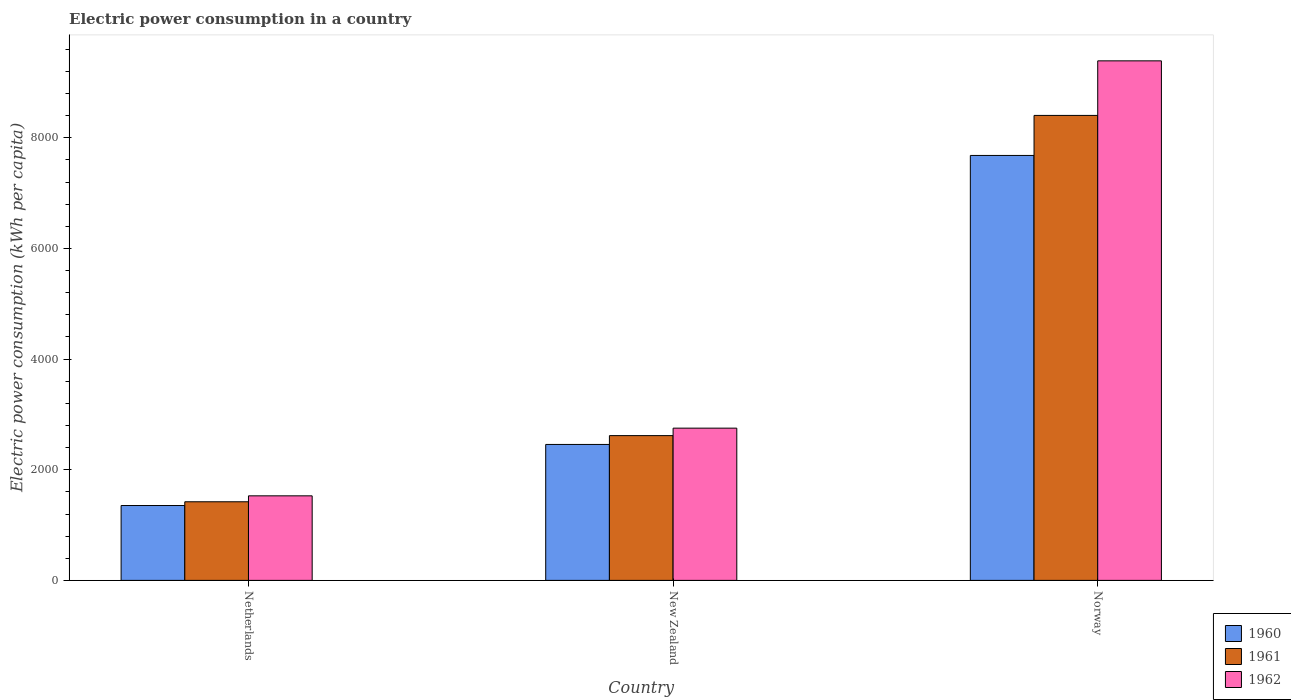How many different coloured bars are there?
Offer a very short reply. 3. Are the number of bars per tick equal to the number of legend labels?
Ensure brevity in your answer.  Yes. How many bars are there on the 3rd tick from the right?
Provide a short and direct response. 3. What is the label of the 3rd group of bars from the left?
Provide a succinct answer. Norway. In how many cases, is the number of bars for a given country not equal to the number of legend labels?
Your answer should be very brief. 0. What is the electric power consumption in in 1961 in Norway?
Your response must be concise. 8404.62. Across all countries, what is the maximum electric power consumption in in 1960?
Keep it short and to the point. 7681.14. Across all countries, what is the minimum electric power consumption in in 1960?
Make the answer very short. 1353.4. In which country was the electric power consumption in in 1960 maximum?
Keep it short and to the point. Norway. What is the total electric power consumption in in 1961 in the graph?
Provide a succinct answer. 1.24e+04. What is the difference between the electric power consumption in in 1961 in New Zealand and that in Norway?
Provide a short and direct response. -5787.77. What is the difference between the electric power consumption in in 1961 in New Zealand and the electric power consumption in in 1962 in Norway?
Give a very brief answer. -6774.12. What is the average electric power consumption in in 1961 per country?
Ensure brevity in your answer.  4147.5. What is the difference between the electric power consumption in of/in 1960 and electric power consumption in of/in 1961 in Norway?
Your response must be concise. -723.48. What is the ratio of the electric power consumption in in 1960 in Netherlands to that in Norway?
Ensure brevity in your answer.  0.18. Is the difference between the electric power consumption in in 1960 in Netherlands and Norway greater than the difference between the electric power consumption in in 1961 in Netherlands and Norway?
Your answer should be very brief. Yes. What is the difference between the highest and the second highest electric power consumption in in 1962?
Your answer should be compact. -7862.48. What is the difference between the highest and the lowest electric power consumption in in 1961?
Provide a short and direct response. 6983.59. What does the 3rd bar from the left in Norway represents?
Give a very brief answer. 1962. What is the difference between two consecutive major ticks on the Y-axis?
Provide a succinct answer. 2000. Where does the legend appear in the graph?
Your answer should be compact. Bottom right. How many legend labels are there?
Your answer should be very brief. 3. How are the legend labels stacked?
Your response must be concise. Vertical. What is the title of the graph?
Provide a succinct answer. Electric power consumption in a country. Does "2003" appear as one of the legend labels in the graph?
Offer a very short reply. No. What is the label or title of the X-axis?
Make the answer very short. Country. What is the label or title of the Y-axis?
Make the answer very short. Electric power consumption (kWh per capita). What is the Electric power consumption (kWh per capita) of 1960 in Netherlands?
Offer a terse response. 1353.4. What is the Electric power consumption (kWh per capita) of 1961 in Netherlands?
Offer a very short reply. 1421.03. What is the Electric power consumption (kWh per capita) in 1962 in Netherlands?
Make the answer very short. 1528.5. What is the Electric power consumption (kWh per capita) in 1960 in New Zealand?
Keep it short and to the point. 2457.21. What is the Electric power consumption (kWh per capita) in 1961 in New Zealand?
Give a very brief answer. 2616.85. What is the Electric power consumption (kWh per capita) of 1962 in New Zealand?
Your answer should be very brief. 2751.81. What is the Electric power consumption (kWh per capita) in 1960 in Norway?
Keep it short and to the point. 7681.14. What is the Electric power consumption (kWh per capita) in 1961 in Norway?
Your answer should be very brief. 8404.62. What is the Electric power consumption (kWh per capita) in 1962 in Norway?
Provide a short and direct response. 9390.98. Across all countries, what is the maximum Electric power consumption (kWh per capita) in 1960?
Provide a succinct answer. 7681.14. Across all countries, what is the maximum Electric power consumption (kWh per capita) in 1961?
Make the answer very short. 8404.62. Across all countries, what is the maximum Electric power consumption (kWh per capita) in 1962?
Provide a succinct answer. 9390.98. Across all countries, what is the minimum Electric power consumption (kWh per capita) in 1960?
Keep it short and to the point. 1353.4. Across all countries, what is the minimum Electric power consumption (kWh per capita) in 1961?
Provide a short and direct response. 1421.03. Across all countries, what is the minimum Electric power consumption (kWh per capita) in 1962?
Offer a very short reply. 1528.5. What is the total Electric power consumption (kWh per capita) in 1960 in the graph?
Ensure brevity in your answer.  1.15e+04. What is the total Electric power consumption (kWh per capita) of 1961 in the graph?
Provide a succinct answer. 1.24e+04. What is the total Electric power consumption (kWh per capita) in 1962 in the graph?
Provide a short and direct response. 1.37e+04. What is the difference between the Electric power consumption (kWh per capita) in 1960 in Netherlands and that in New Zealand?
Offer a very short reply. -1103.81. What is the difference between the Electric power consumption (kWh per capita) of 1961 in Netherlands and that in New Zealand?
Offer a very short reply. -1195.82. What is the difference between the Electric power consumption (kWh per capita) in 1962 in Netherlands and that in New Zealand?
Give a very brief answer. -1223.31. What is the difference between the Electric power consumption (kWh per capita) in 1960 in Netherlands and that in Norway?
Offer a very short reply. -6327.74. What is the difference between the Electric power consumption (kWh per capita) of 1961 in Netherlands and that in Norway?
Your answer should be very brief. -6983.59. What is the difference between the Electric power consumption (kWh per capita) of 1962 in Netherlands and that in Norway?
Keep it short and to the point. -7862.48. What is the difference between the Electric power consumption (kWh per capita) of 1960 in New Zealand and that in Norway?
Offer a terse response. -5223.94. What is the difference between the Electric power consumption (kWh per capita) in 1961 in New Zealand and that in Norway?
Offer a terse response. -5787.77. What is the difference between the Electric power consumption (kWh per capita) of 1962 in New Zealand and that in Norway?
Ensure brevity in your answer.  -6639.17. What is the difference between the Electric power consumption (kWh per capita) in 1960 in Netherlands and the Electric power consumption (kWh per capita) in 1961 in New Zealand?
Ensure brevity in your answer.  -1263.45. What is the difference between the Electric power consumption (kWh per capita) of 1960 in Netherlands and the Electric power consumption (kWh per capita) of 1962 in New Zealand?
Provide a short and direct response. -1398.41. What is the difference between the Electric power consumption (kWh per capita) of 1961 in Netherlands and the Electric power consumption (kWh per capita) of 1962 in New Zealand?
Provide a succinct answer. -1330.78. What is the difference between the Electric power consumption (kWh per capita) in 1960 in Netherlands and the Electric power consumption (kWh per capita) in 1961 in Norway?
Offer a very short reply. -7051.22. What is the difference between the Electric power consumption (kWh per capita) of 1960 in Netherlands and the Electric power consumption (kWh per capita) of 1962 in Norway?
Offer a very short reply. -8037.58. What is the difference between the Electric power consumption (kWh per capita) in 1961 in Netherlands and the Electric power consumption (kWh per capita) in 1962 in Norway?
Ensure brevity in your answer.  -7969.94. What is the difference between the Electric power consumption (kWh per capita) in 1960 in New Zealand and the Electric power consumption (kWh per capita) in 1961 in Norway?
Provide a succinct answer. -5947.42. What is the difference between the Electric power consumption (kWh per capita) of 1960 in New Zealand and the Electric power consumption (kWh per capita) of 1962 in Norway?
Your answer should be compact. -6933.77. What is the difference between the Electric power consumption (kWh per capita) of 1961 in New Zealand and the Electric power consumption (kWh per capita) of 1962 in Norway?
Provide a short and direct response. -6774.12. What is the average Electric power consumption (kWh per capita) of 1960 per country?
Give a very brief answer. 3830.58. What is the average Electric power consumption (kWh per capita) of 1961 per country?
Offer a very short reply. 4147.5. What is the average Electric power consumption (kWh per capita) of 1962 per country?
Give a very brief answer. 4557.1. What is the difference between the Electric power consumption (kWh per capita) in 1960 and Electric power consumption (kWh per capita) in 1961 in Netherlands?
Provide a short and direct response. -67.63. What is the difference between the Electric power consumption (kWh per capita) in 1960 and Electric power consumption (kWh per capita) in 1962 in Netherlands?
Provide a succinct answer. -175.1. What is the difference between the Electric power consumption (kWh per capita) in 1961 and Electric power consumption (kWh per capita) in 1962 in Netherlands?
Give a very brief answer. -107.47. What is the difference between the Electric power consumption (kWh per capita) of 1960 and Electric power consumption (kWh per capita) of 1961 in New Zealand?
Your answer should be very brief. -159.65. What is the difference between the Electric power consumption (kWh per capita) of 1960 and Electric power consumption (kWh per capita) of 1962 in New Zealand?
Provide a short and direct response. -294.61. What is the difference between the Electric power consumption (kWh per capita) in 1961 and Electric power consumption (kWh per capita) in 1962 in New Zealand?
Give a very brief answer. -134.96. What is the difference between the Electric power consumption (kWh per capita) of 1960 and Electric power consumption (kWh per capita) of 1961 in Norway?
Your response must be concise. -723.48. What is the difference between the Electric power consumption (kWh per capita) in 1960 and Electric power consumption (kWh per capita) in 1962 in Norway?
Keep it short and to the point. -1709.84. What is the difference between the Electric power consumption (kWh per capita) of 1961 and Electric power consumption (kWh per capita) of 1962 in Norway?
Your response must be concise. -986.36. What is the ratio of the Electric power consumption (kWh per capita) in 1960 in Netherlands to that in New Zealand?
Provide a short and direct response. 0.55. What is the ratio of the Electric power consumption (kWh per capita) in 1961 in Netherlands to that in New Zealand?
Your response must be concise. 0.54. What is the ratio of the Electric power consumption (kWh per capita) in 1962 in Netherlands to that in New Zealand?
Ensure brevity in your answer.  0.56. What is the ratio of the Electric power consumption (kWh per capita) in 1960 in Netherlands to that in Norway?
Provide a succinct answer. 0.18. What is the ratio of the Electric power consumption (kWh per capita) of 1961 in Netherlands to that in Norway?
Ensure brevity in your answer.  0.17. What is the ratio of the Electric power consumption (kWh per capita) in 1962 in Netherlands to that in Norway?
Offer a very short reply. 0.16. What is the ratio of the Electric power consumption (kWh per capita) in 1960 in New Zealand to that in Norway?
Provide a short and direct response. 0.32. What is the ratio of the Electric power consumption (kWh per capita) of 1961 in New Zealand to that in Norway?
Ensure brevity in your answer.  0.31. What is the ratio of the Electric power consumption (kWh per capita) in 1962 in New Zealand to that in Norway?
Offer a terse response. 0.29. What is the difference between the highest and the second highest Electric power consumption (kWh per capita) of 1960?
Provide a short and direct response. 5223.94. What is the difference between the highest and the second highest Electric power consumption (kWh per capita) in 1961?
Give a very brief answer. 5787.77. What is the difference between the highest and the second highest Electric power consumption (kWh per capita) in 1962?
Your answer should be compact. 6639.17. What is the difference between the highest and the lowest Electric power consumption (kWh per capita) of 1960?
Your answer should be compact. 6327.74. What is the difference between the highest and the lowest Electric power consumption (kWh per capita) of 1961?
Keep it short and to the point. 6983.59. What is the difference between the highest and the lowest Electric power consumption (kWh per capita) of 1962?
Give a very brief answer. 7862.48. 